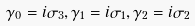Convert formula to latex. <formula><loc_0><loc_0><loc_500><loc_500>\gamma _ { 0 } = i \sigma _ { 3 } , \gamma _ { 1 } = i \sigma _ { 1 } , \gamma _ { 2 } = i \sigma _ { 2 }</formula> 